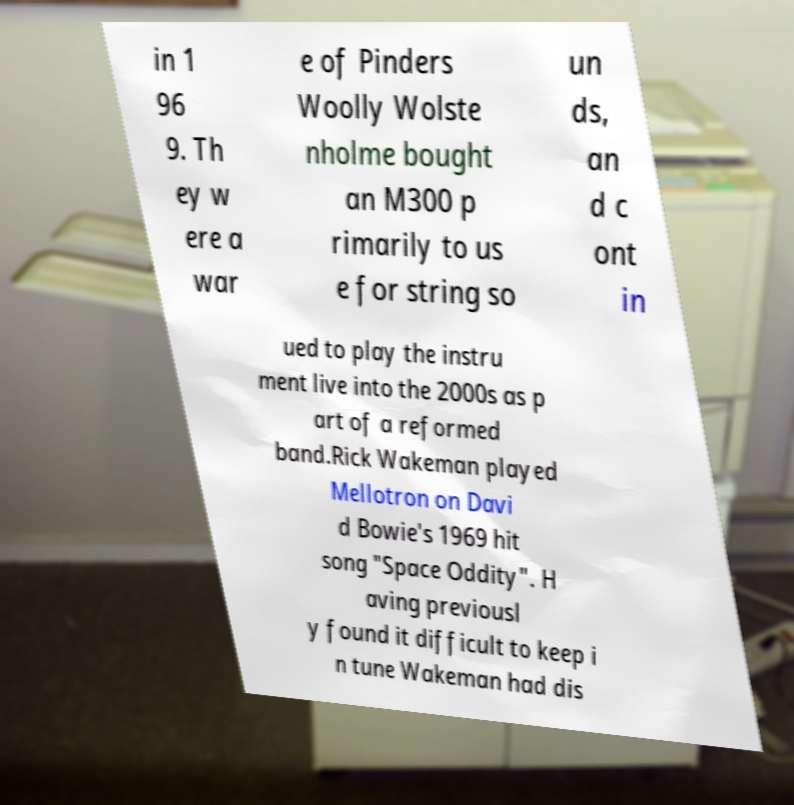Could you assist in decoding the text presented in this image and type it out clearly? in 1 96 9. Th ey w ere a war e of Pinders Woolly Wolste nholme bought an M300 p rimarily to us e for string so un ds, an d c ont in ued to play the instru ment live into the 2000s as p art of a reformed band.Rick Wakeman played Mellotron on Davi d Bowie's 1969 hit song "Space Oddity". H aving previousl y found it difficult to keep i n tune Wakeman had dis 